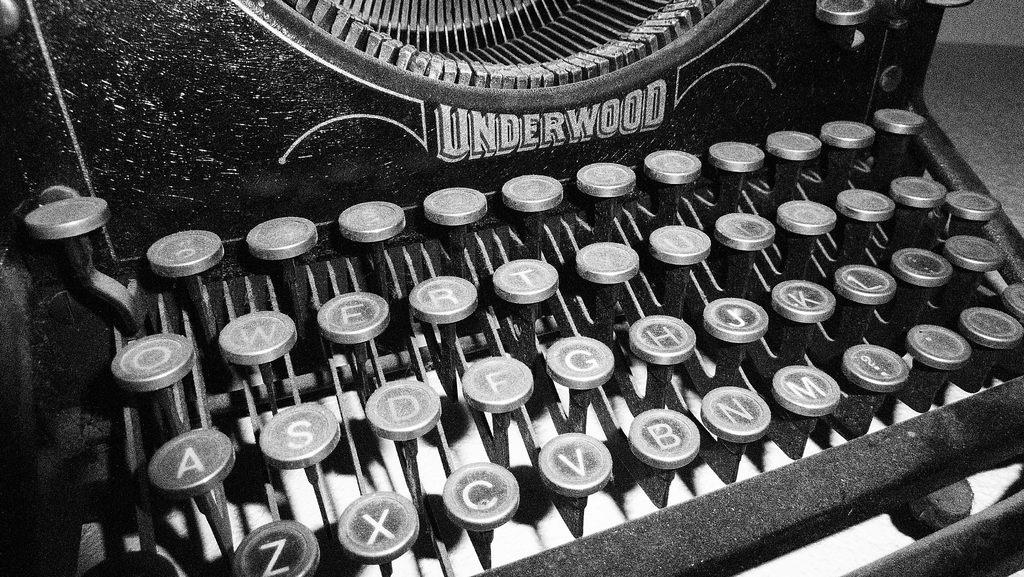Provide a one-sentence caption for the provided image. a black and white photo of an underwood typewriter. 